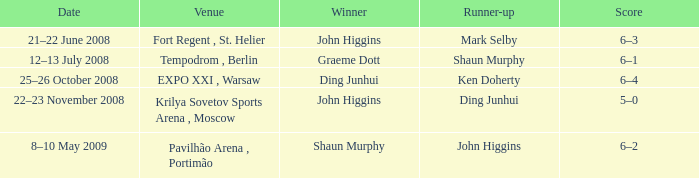When was the match that had Shaun Murphy as runner-up? 12–13 July 2008. 